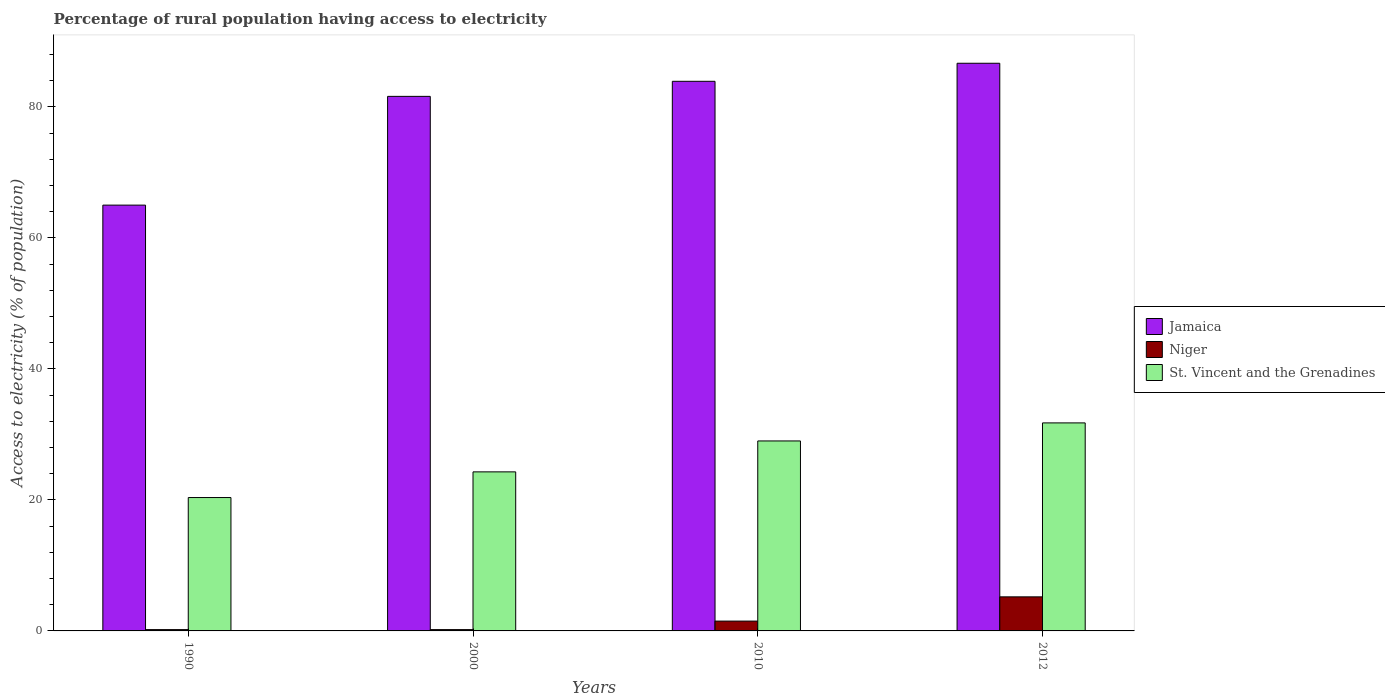How many different coloured bars are there?
Your response must be concise. 3. How many groups of bars are there?
Ensure brevity in your answer.  4. Are the number of bars on each tick of the X-axis equal?
Your response must be concise. Yes. What is the percentage of rural population having access to electricity in Jamaica in 2012?
Offer a terse response. 86.65. Across all years, what is the maximum percentage of rural population having access to electricity in Niger?
Offer a terse response. 5.2. In which year was the percentage of rural population having access to electricity in Jamaica maximum?
Provide a short and direct response. 2012. What is the total percentage of rural population having access to electricity in St. Vincent and the Grenadines in the graph?
Your answer should be very brief. 105.4. What is the difference between the percentage of rural population having access to electricity in St. Vincent and the Grenadines in 1990 and that in 2000?
Make the answer very short. -3.92. What is the difference between the percentage of rural population having access to electricity in St. Vincent and the Grenadines in 2000 and the percentage of rural population having access to electricity in Niger in 2010?
Make the answer very short. 22.78. What is the average percentage of rural population having access to electricity in St. Vincent and the Grenadines per year?
Your answer should be very brief. 26.35. In the year 2010, what is the difference between the percentage of rural population having access to electricity in St. Vincent and the Grenadines and percentage of rural population having access to electricity in Niger?
Keep it short and to the point. 27.5. In how many years, is the percentage of rural population having access to electricity in St. Vincent and the Grenadines greater than 16 %?
Give a very brief answer. 4. What is the ratio of the percentage of rural population having access to electricity in Niger in 2010 to that in 2012?
Your answer should be compact. 0.29. Is the percentage of rural population having access to electricity in Niger in 2010 less than that in 2012?
Make the answer very short. Yes. What is the difference between the highest and the second highest percentage of rural population having access to electricity in St. Vincent and the Grenadines?
Give a very brief answer. 2.75. What is the difference between the highest and the lowest percentage of rural population having access to electricity in St. Vincent and the Grenadines?
Ensure brevity in your answer.  11.39. In how many years, is the percentage of rural population having access to electricity in Jamaica greater than the average percentage of rural population having access to electricity in Jamaica taken over all years?
Keep it short and to the point. 3. What does the 2nd bar from the left in 2010 represents?
Make the answer very short. Niger. What does the 3rd bar from the right in 2010 represents?
Your response must be concise. Jamaica. Is it the case that in every year, the sum of the percentage of rural population having access to electricity in Jamaica and percentage of rural population having access to electricity in Niger is greater than the percentage of rural population having access to electricity in St. Vincent and the Grenadines?
Give a very brief answer. Yes. How many bars are there?
Your response must be concise. 12. Are the values on the major ticks of Y-axis written in scientific E-notation?
Make the answer very short. No. Does the graph contain any zero values?
Your answer should be compact. No. Does the graph contain grids?
Keep it short and to the point. No. How are the legend labels stacked?
Give a very brief answer. Vertical. What is the title of the graph?
Offer a terse response. Percentage of rural population having access to electricity. What is the label or title of the Y-axis?
Offer a very short reply. Access to electricity (% of population). What is the Access to electricity (% of population) in St. Vincent and the Grenadines in 1990?
Keep it short and to the point. 20.36. What is the Access to electricity (% of population) of Jamaica in 2000?
Keep it short and to the point. 81.6. What is the Access to electricity (% of population) in St. Vincent and the Grenadines in 2000?
Provide a succinct answer. 24.28. What is the Access to electricity (% of population) in Jamaica in 2010?
Offer a terse response. 83.9. What is the Access to electricity (% of population) in St. Vincent and the Grenadines in 2010?
Ensure brevity in your answer.  29. What is the Access to electricity (% of population) of Jamaica in 2012?
Provide a succinct answer. 86.65. What is the Access to electricity (% of population) in Niger in 2012?
Your response must be concise. 5.2. What is the Access to electricity (% of population) of St. Vincent and the Grenadines in 2012?
Offer a terse response. 31.75. Across all years, what is the maximum Access to electricity (% of population) in Jamaica?
Offer a terse response. 86.65. Across all years, what is the maximum Access to electricity (% of population) of St. Vincent and the Grenadines?
Provide a short and direct response. 31.75. Across all years, what is the minimum Access to electricity (% of population) in Niger?
Your answer should be compact. 0.2. Across all years, what is the minimum Access to electricity (% of population) of St. Vincent and the Grenadines?
Ensure brevity in your answer.  20.36. What is the total Access to electricity (% of population) of Jamaica in the graph?
Offer a very short reply. 317.15. What is the total Access to electricity (% of population) in Niger in the graph?
Provide a short and direct response. 7.1. What is the total Access to electricity (% of population) in St. Vincent and the Grenadines in the graph?
Your answer should be compact. 105.4. What is the difference between the Access to electricity (% of population) of Jamaica in 1990 and that in 2000?
Your answer should be very brief. -16.6. What is the difference between the Access to electricity (% of population) of Niger in 1990 and that in 2000?
Offer a very short reply. 0. What is the difference between the Access to electricity (% of population) in St. Vincent and the Grenadines in 1990 and that in 2000?
Your response must be concise. -3.92. What is the difference between the Access to electricity (% of population) of Jamaica in 1990 and that in 2010?
Provide a succinct answer. -18.9. What is the difference between the Access to electricity (% of population) of Niger in 1990 and that in 2010?
Provide a succinct answer. -1.3. What is the difference between the Access to electricity (% of population) in St. Vincent and the Grenadines in 1990 and that in 2010?
Provide a succinct answer. -8.64. What is the difference between the Access to electricity (% of population) in Jamaica in 1990 and that in 2012?
Your answer should be compact. -21.65. What is the difference between the Access to electricity (% of population) of St. Vincent and the Grenadines in 1990 and that in 2012?
Provide a succinct answer. -11.39. What is the difference between the Access to electricity (% of population) in Jamaica in 2000 and that in 2010?
Give a very brief answer. -2.3. What is the difference between the Access to electricity (% of population) in St. Vincent and the Grenadines in 2000 and that in 2010?
Your answer should be compact. -4.72. What is the difference between the Access to electricity (% of population) of Jamaica in 2000 and that in 2012?
Offer a very short reply. -5.05. What is the difference between the Access to electricity (% of population) in St. Vincent and the Grenadines in 2000 and that in 2012?
Keep it short and to the point. -7.47. What is the difference between the Access to electricity (% of population) of Jamaica in 2010 and that in 2012?
Provide a short and direct response. -2.75. What is the difference between the Access to electricity (% of population) in Niger in 2010 and that in 2012?
Ensure brevity in your answer.  -3.7. What is the difference between the Access to electricity (% of population) of St. Vincent and the Grenadines in 2010 and that in 2012?
Provide a short and direct response. -2.75. What is the difference between the Access to electricity (% of population) of Jamaica in 1990 and the Access to electricity (% of population) of Niger in 2000?
Provide a short and direct response. 64.8. What is the difference between the Access to electricity (% of population) in Jamaica in 1990 and the Access to electricity (% of population) in St. Vincent and the Grenadines in 2000?
Your response must be concise. 40.72. What is the difference between the Access to electricity (% of population) of Niger in 1990 and the Access to electricity (% of population) of St. Vincent and the Grenadines in 2000?
Offer a terse response. -24.08. What is the difference between the Access to electricity (% of population) in Jamaica in 1990 and the Access to electricity (% of population) in Niger in 2010?
Your response must be concise. 63.5. What is the difference between the Access to electricity (% of population) of Niger in 1990 and the Access to electricity (% of population) of St. Vincent and the Grenadines in 2010?
Your answer should be compact. -28.8. What is the difference between the Access to electricity (% of population) in Jamaica in 1990 and the Access to electricity (% of population) in Niger in 2012?
Provide a succinct answer. 59.8. What is the difference between the Access to electricity (% of population) of Jamaica in 1990 and the Access to electricity (% of population) of St. Vincent and the Grenadines in 2012?
Your response must be concise. 33.25. What is the difference between the Access to electricity (% of population) of Niger in 1990 and the Access to electricity (% of population) of St. Vincent and the Grenadines in 2012?
Your answer should be compact. -31.55. What is the difference between the Access to electricity (% of population) in Jamaica in 2000 and the Access to electricity (% of population) in Niger in 2010?
Offer a terse response. 80.1. What is the difference between the Access to electricity (% of population) in Jamaica in 2000 and the Access to electricity (% of population) in St. Vincent and the Grenadines in 2010?
Make the answer very short. 52.6. What is the difference between the Access to electricity (% of population) of Niger in 2000 and the Access to electricity (% of population) of St. Vincent and the Grenadines in 2010?
Provide a short and direct response. -28.8. What is the difference between the Access to electricity (% of population) in Jamaica in 2000 and the Access to electricity (% of population) in Niger in 2012?
Offer a terse response. 76.4. What is the difference between the Access to electricity (% of population) of Jamaica in 2000 and the Access to electricity (% of population) of St. Vincent and the Grenadines in 2012?
Make the answer very short. 49.85. What is the difference between the Access to electricity (% of population) in Niger in 2000 and the Access to electricity (% of population) in St. Vincent and the Grenadines in 2012?
Give a very brief answer. -31.55. What is the difference between the Access to electricity (% of population) in Jamaica in 2010 and the Access to electricity (% of population) in Niger in 2012?
Give a very brief answer. 78.7. What is the difference between the Access to electricity (% of population) of Jamaica in 2010 and the Access to electricity (% of population) of St. Vincent and the Grenadines in 2012?
Provide a succinct answer. 52.15. What is the difference between the Access to electricity (% of population) in Niger in 2010 and the Access to electricity (% of population) in St. Vincent and the Grenadines in 2012?
Give a very brief answer. -30.25. What is the average Access to electricity (% of population) of Jamaica per year?
Ensure brevity in your answer.  79.29. What is the average Access to electricity (% of population) of Niger per year?
Your answer should be compact. 1.77. What is the average Access to electricity (% of population) in St. Vincent and the Grenadines per year?
Keep it short and to the point. 26.35. In the year 1990, what is the difference between the Access to electricity (% of population) in Jamaica and Access to electricity (% of population) in Niger?
Your answer should be compact. 64.8. In the year 1990, what is the difference between the Access to electricity (% of population) of Jamaica and Access to electricity (% of population) of St. Vincent and the Grenadines?
Provide a short and direct response. 44.64. In the year 1990, what is the difference between the Access to electricity (% of population) in Niger and Access to electricity (% of population) in St. Vincent and the Grenadines?
Keep it short and to the point. -20.16. In the year 2000, what is the difference between the Access to electricity (% of population) of Jamaica and Access to electricity (% of population) of Niger?
Your response must be concise. 81.4. In the year 2000, what is the difference between the Access to electricity (% of population) of Jamaica and Access to electricity (% of population) of St. Vincent and the Grenadines?
Give a very brief answer. 57.32. In the year 2000, what is the difference between the Access to electricity (% of population) in Niger and Access to electricity (% of population) in St. Vincent and the Grenadines?
Ensure brevity in your answer.  -24.08. In the year 2010, what is the difference between the Access to electricity (% of population) of Jamaica and Access to electricity (% of population) of Niger?
Provide a short and direct response. 82.4. In the year 2010, what is the difference between the Access to electricity (% of population) in Jamaica and Access to electricity (% of population) in St. Vincent and the Grenadines?
Make the answer very short. 54.9. In the year 2010, what is the difference between the Access to electricity (% of population) in Niger and Access to electricity (% of population) in St. Vincent and the Grenadines?
Provide a succinct answer. -27.5. In the year 2012, what is the difference between the Access to electricity (% of population) in Jamaica and Access to electricity (% of population) in Niger?
Your answer should be compact. 81.45. In the year 2012, what is the difference between the Access to electricity (% of population) of Jamaica and Access to electricity (% of population) of St. Vincent and the Grenadines?
Provide a short and direct response. 54.9. In the year 2012, what is the difference between the Access to electricity (% of population) in Niger and Access to electricity (% of population) in St. Vincent and the Grenadines?
Your answer should be compact. -26.55. What is the ratio of the Access to electricity (% of population) in Jamaica in 1990 to that in 2000?
Offer a terse response. 0.8. What is the ratio of the Access to electricity (% of population) in Niger in 1990 to that in 2000?
Offer a very short reply. 1. What is the ratio of the Access to electricity (% of population) in St. Vincent and the Grenadines in 1990 to that in 2000?
Your answer should be very brief. 0.84. What is the ratio of the Access to electricity (% of population) of Jamaica in 1990 to that in 2010?
Keep it short and to the point. 0.77. What is the ratio of the Access to electricity (% of population) of Niger in 1990 to that in 2010?
Provide a succinct answer. 0.13. What is the ratio of the Access to electricity (% of population) in St. Vincent and the Grenadines in 1990 to that in 2010?
Your response must be concise. 0.7. What is the ratio of the Access to electricity (% of population) of Jamaica in 1990 to that in 2012?
Ensure brevity in your answer.  0.75. What is the ratio of the Access to electricity (% of population) in Niger in 1990 to that in 2012?
Ensure brevity in your answer.  0.04. What is the ratio of the Access to electricity (% of population) of St. Vincent and the Grenadines in 1990 to that in 2012?
Keep it short and to the point. 0.64. What is the ratio of the Access to electricity (% of population) in Jamaica in 2000 to that in 2010?
Offer a terse response. 0.97. What is the ratio of the Access to electricity (% of population) of Niger in 2000 to that in 2010?
Your answer should be very brief. 0.13. What is the ratio of the Access to electricity (% of population) of St. Vincent and the Grenadines in 2000 to that in 2010?
Your answer should be very brief. 0.84. What is the ratio of the Access to electricity (% of population) in Jamaica in 2000 to that in 2012?
Offer a very short reply. 0.94. What is the ratio of the Access to electricity (% of population) of Niger in 2000 to that in 2012?
Provide a short and direct response. 0.04. What is the ratio of the Access to electricity (% of population) in St. Vincent and the Grenadines in 2000 to that in 2012?
Your response must be concise. 0.76. What is the ratio of the Access to electricity (% of population) in Jamaica in 2010 to that in 2012?
Make the answer very short. 0.97. What is the ratio of the Access to electricity (% of population) in Niger in 2010 to that in 2012?
Your response must be concise. 0.29. What is the ratio of the Access to electricity (% of population) in St. Vincent and the Grenadines in 2010 to that in 2012?
Your answer should be very brief. 0.91. What is the difference between the highest and the second highest Access to electricity (% of population) in Jamaica?
Provide a short and direct response. 2.75. What is the difference between the highest and the second highest Access to electricity (% of population) of Niger?
Your answer should be very brief. 3.7. What is the difference between the highest and the second highest Access to electricity (% of population) of St. Vincent and the Grenadines?
Offer a terse response. 2.75. What is the difference between the highest and the lowest Access to electricity (% of population) of Jamaica?
Your answer should be very brief. 21.65. What is the difference between the highest and the lowest Access to electricity (% of population) in St. Vincent and the Grenadines?
Ensure brevity in your answer.  11.39. 